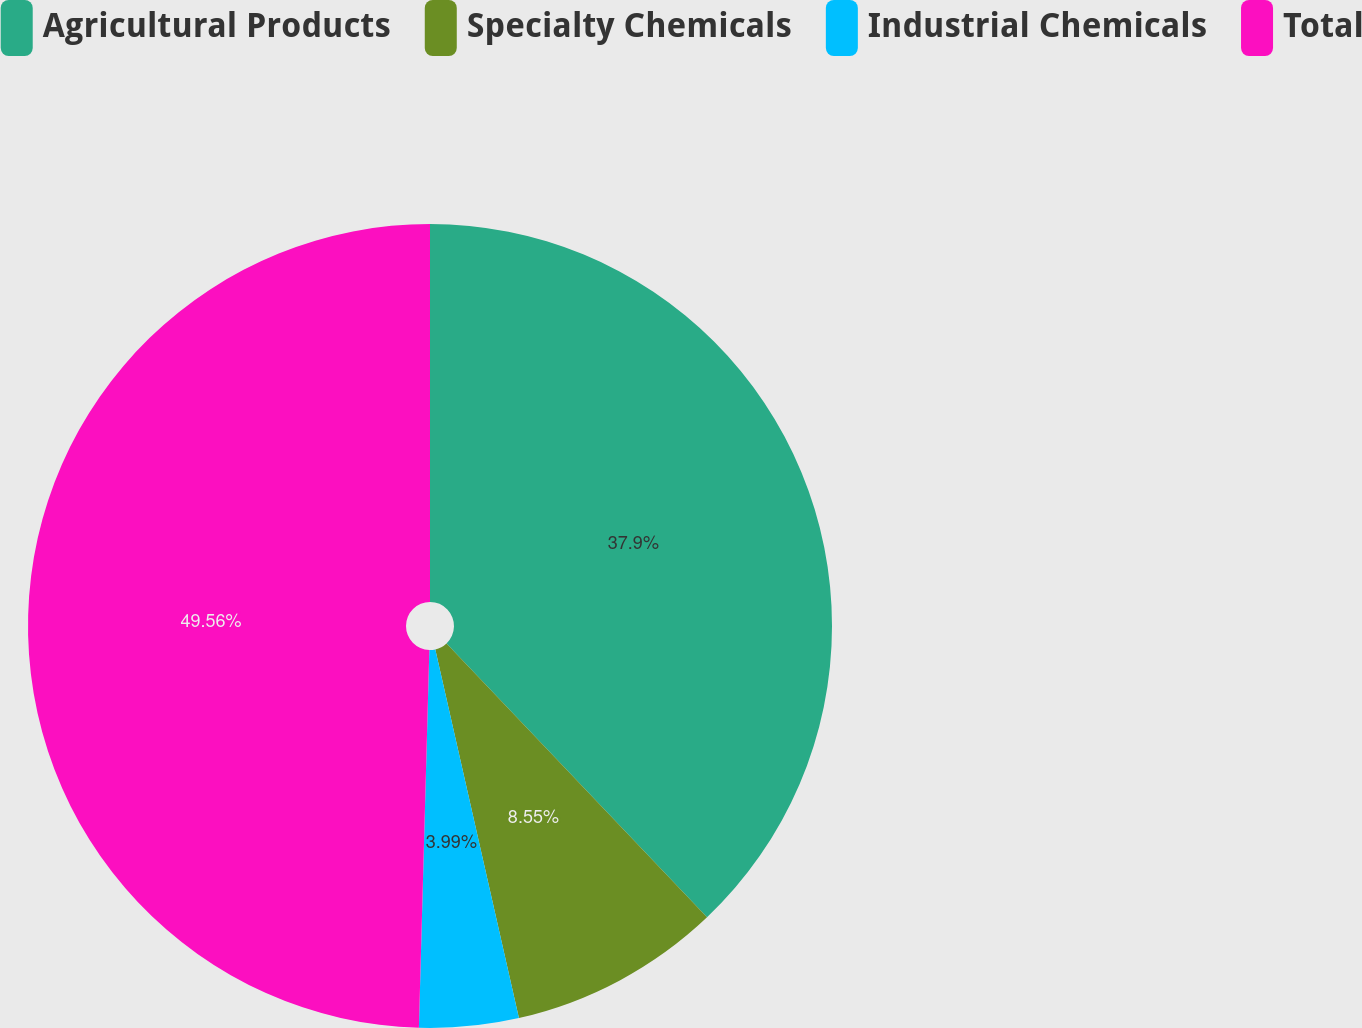Convert chart. <chart><loc_0><loc_0><loc_500><loc_500><pie_chart><fcel>Agricultural Products<fcel>Specialty Chemicals<fcel>Industrial Chemicals<fcel>Total<nl><fcel>37.9%<fcel>8.55%<fcel>3.99%<fcel>49.56%<nl></chart> 